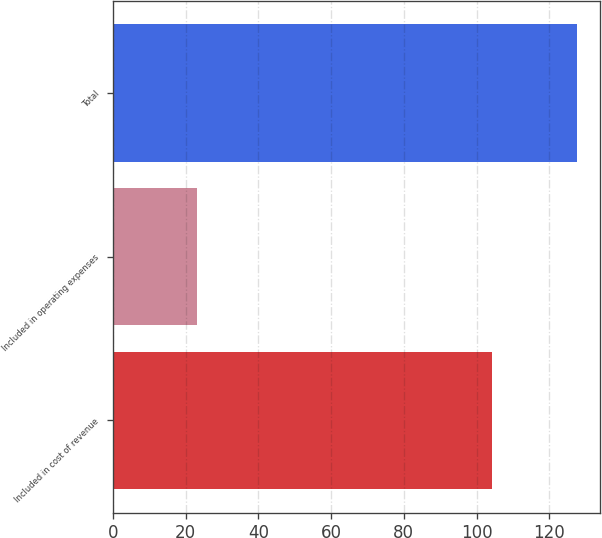Convert chart. <chart><loc_0><loc_0><loc_500><loc_500><bar_chart><fcel>Included in cost of revenue<fcel>Included in operating expenses<fcel>Total<nl><fcel>104.3<fcel>23.2<fcel>127.5<nl></chart> 